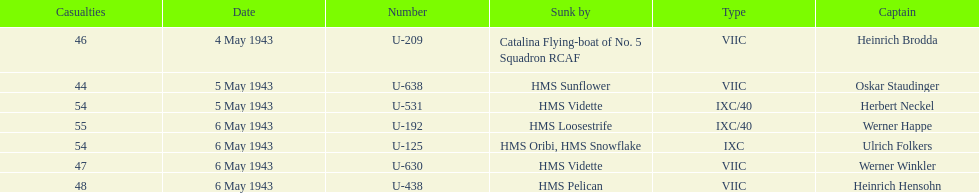Which sunk u-boat experienced the greatest number of casualties? U-192. 